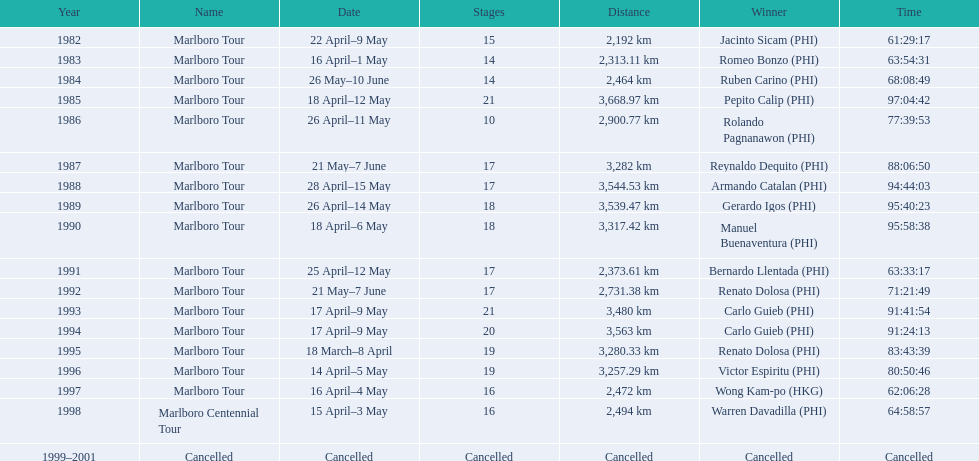What racial category did warren davadilla join in 1998? Marlboro Centennial Tour. How long was davadilla's completion time for the marlboro centennial tour? 64:58:57. 